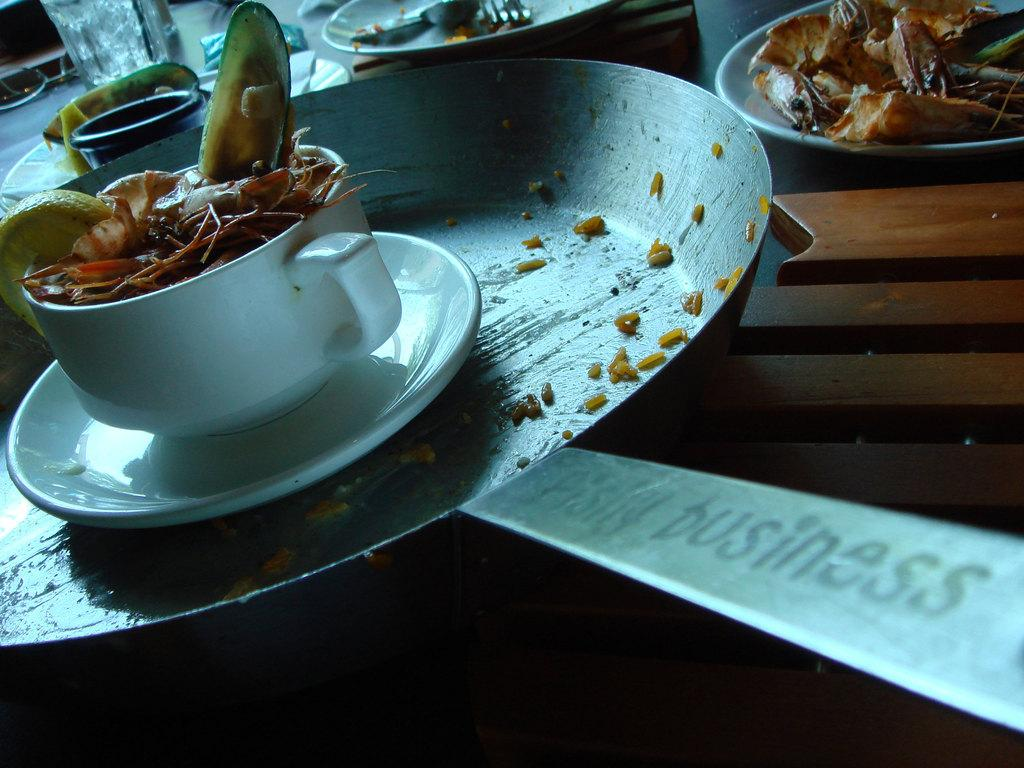What is on the plate in the image? There is food placed on a plate in the image. What is in the cup in the image? There is food waste in a cup in the image. Where are the utensils located in the image? The utensils are placed on a table in the image. What type of farm can be seen in the image? There is no farm present in the image. What statement is being made by the food waste in the cup? The food waste in the cup is not making a statement; it is simply waste. 